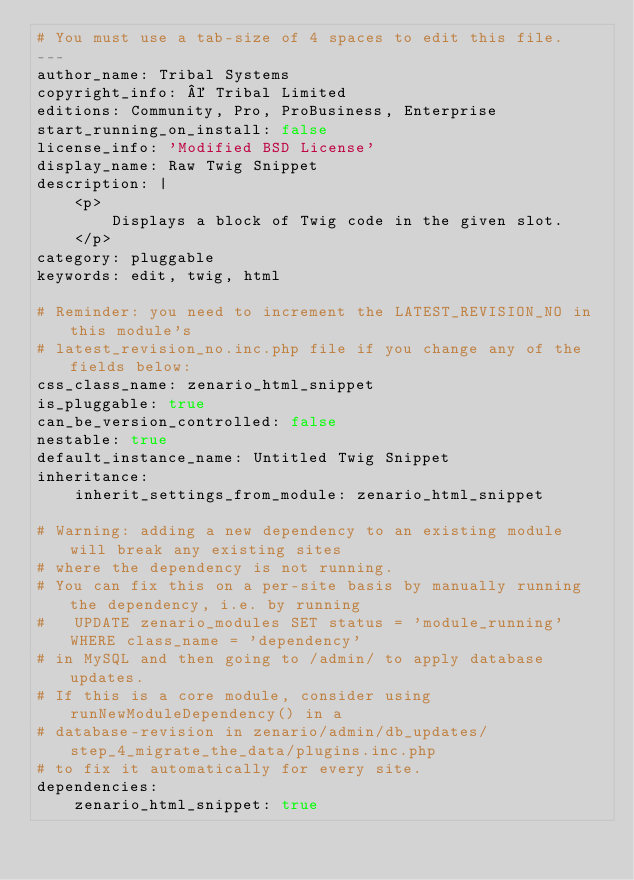<code> <loc_0><loc_0><loc_500><loc_500><_YAML_># You must use a tab-size of 4 spaces to edit this file.
---
author_name: Tribal Systems
copyright_info: © Tribal Limited
editions: Community, Pro, ProBusiness, Enterprise
start_running_on_install: false
license_info: 'Modified BSD License'
display_name: Raw Twig Snippet
description: |
    <p>
        Displays a block of Twig code in the given slot.
    </p>
category: pluggable
keywords: edit, twig, html

# Reminder: you need to increment the LATEST_REVISION_NO in this module's
# latest_revision_no.inc.php file if you change any of the fields below:
css_class_name: zenario_html_snippet
is_pluggable: true
can_be_version_controlled: false
nestable: true
default_instance_name: Untitled Twig Snippet
inheritance:
    inherit_settings_from_module: zenario_html_snippet

# Warning: adding a new dependency to an existing module will break any existing sites
# where the dependency is not running.
# You can fix this on a per-site basis by manually running the dependency, i.e. by running
#   UPDATE zenario_modules SET status = 'module_running' WHERE class_name = 'dependency'
# in MySQL and then going to /admin/ to apply database updates.
# If this is a core module, consider using runNewModuleDependency() in a 
# database-revision in zenario/admin/db_updates/step_4_migrate_the_data/plugins.inc.php
# to fix it automatically for every site.
dependencies:
    zenario_html_snippet: true</code> 